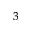<formula> <loc_0><loc_0><loc_500><loc_500>^ { 3 }</formula> 